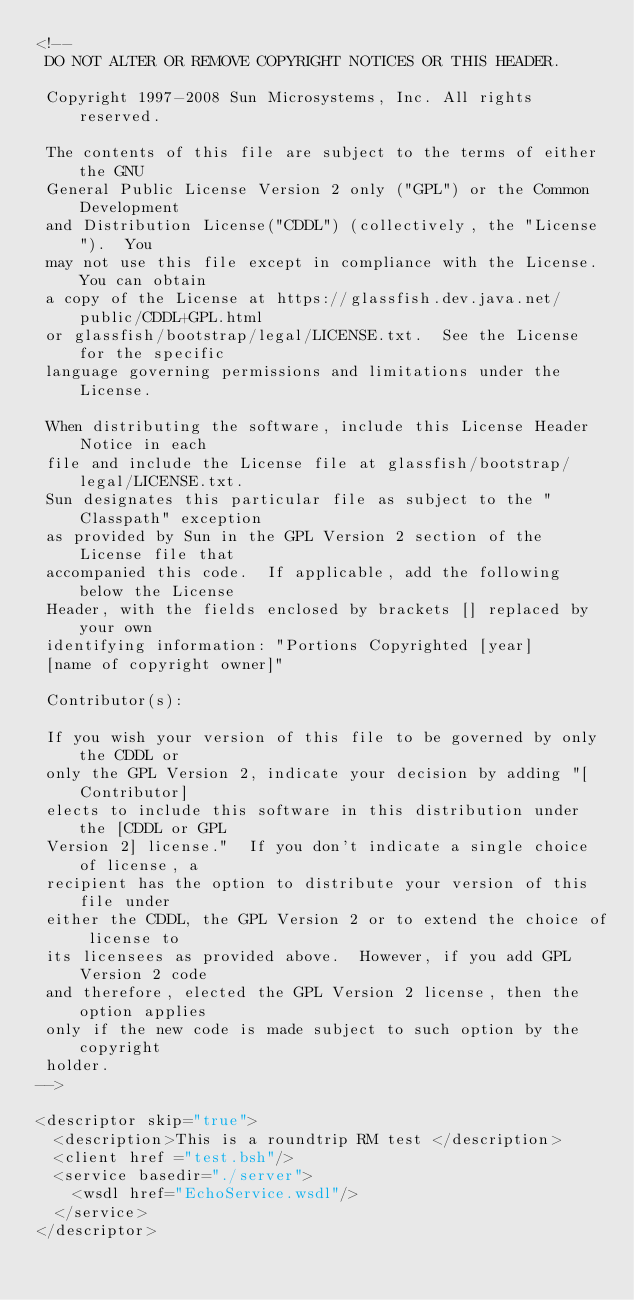Convert code to text. <code><loc_0><loc_0><loc_500><loc_500><_XML_><!--
 DO NOT ALTER OR REMOVE COPYRIGHT NOTICES OR THIS HEADER.
 
 Copyright 1997-2008 Sun Microsystems, Inc. All rights reserved.
 
 The contents of this file are subject to the terms of either the GNU
 General Public License Version 2 only ("GPL") or the Common Development
 and Distribution License("CDDL") (collectively, the "License").  You
 may not use this file except in compliance with the License. You can obtain
 a copy of the License at https://glassfish.dev.java.net/public/CDDL+GPL.html
 or glassfish/bootstrap/legal/LICENSE.txt.  See the License for the specific
 language governing permissions and limitations under the License.
 
 When distributing the software, include this License Header Notice in each
 file and include the License file at glassfish/bootstrap/legal/LICENSE.txt.
 Sun designates this particular file as subject to the "Classpath" exception
 as provided by Sun in the GPL Version 2 section of the License file that
 accompanied this code.  If applicable, add the following below the License
 Header, with the fields enclosed by brackets [] replaced by your own
 identifying information: "Portions Copyrighted [year]
 [name of copyright owner]"
 
 Contributor(s):
 
 If you wish your version of this file to be governed by only the CDDL or
 only the GPL Version 2, indicate your decision by adding "[Contributor]
 elects to include this software in this distribution under the [CDDL or GPL
 Version 2] license."  If you don't indicate a single choice of license, a
 recipient has the option to distribute your version of this file under
 either the CDDL, the GPL Version 2 or to extend the choice of license to
 its licensees as provided above.  However, if you add GPL Version 2 code
 and therefore, elected the GPL Version 2 license, then the option applies
 only if the new code is made subject to such option by the copyright
 holder.
-->

<descriptor skip="true">
  <description>This is a roundtrip RM test </description>
  <client href ="test.bsh"/>
  <service basedir="./server">
    <wsdl href="EchoService.wsdl"/>
  </service>
</descriptor>

</code> 